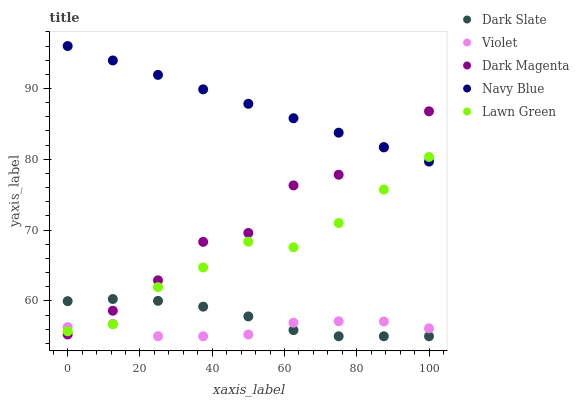Does Violet have the minimum area under the curve?
Answer yes or no. Yes. Does Navy Blue have the maximum area under the curve?
Answer yes or no. Yes. Does Lawn Green have the minimum area under the curve?
Answer yes or no. No. Does Lawn Green have the maximum area under the curve?
Answer yes or no. No. Is Navy Blue the smoothest?
Answer yes or no. Yes. Is Dark Magenta the roughest?
Answer yes or no. Yes. Is Lawn Green the smoothest?
Answer yes or no. No. Is Lawn Green the roughest?
Answer yes or no. No. Does Dark Slate have the lowest value?
Answer yes or no. Yes. Does Lawn Green have the lowest value?
Answer yes or no. No. Does Navy Blue have the highest value?
Answer yes or no. Yes. Does Lawn Green have the highest value?
Answer yes or no. No. Is Violet less than Navy Blue?
Answer yes or no. Yes. Is Navy Blue greater than Dark Slate?
Answer yes or no. Yes. Does Lawn Green intersect Violet?
Answer yes or no. Yes. Is Lawn Green less than Violet?
Answer yes or no. No. Is Lawn Green greater than Violet?
Answer yes or no. No. Does Violet intersect Navy Blue?
Answer yes or no. No. 